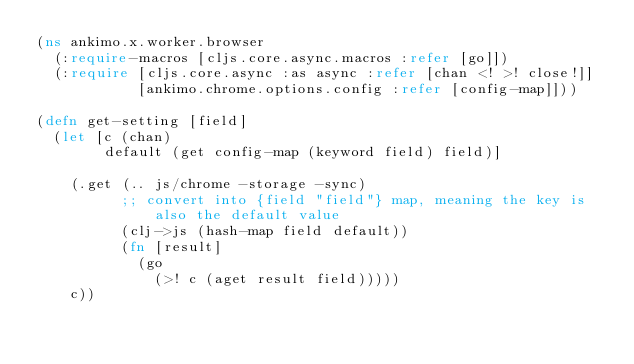Convert code to text. <code><loc_0><loc_0><loc_500><loc_500><_Clojure_>(ns ankimo.x.worker.browser
  (:require-macros [cljs.core.async.macros :refer [go]])
  (:require [cljs.core.async :as async :refer [chan <! >! close!]]
            [ankimo.chrome.options.config :refer [config-map]]))

(defn get-setting [field]
  (let [c (chan)
        default (get config-map (keyword field) field)]

    (.get (.. js/chrome -storage -sync)
          ;; convert into {field "field"} map, meaning the key is also the default value
          (clj->js (hash-map field default))
          (fn [result]
            (go
              (>! c (aget result field)))))
    c))
</code> 